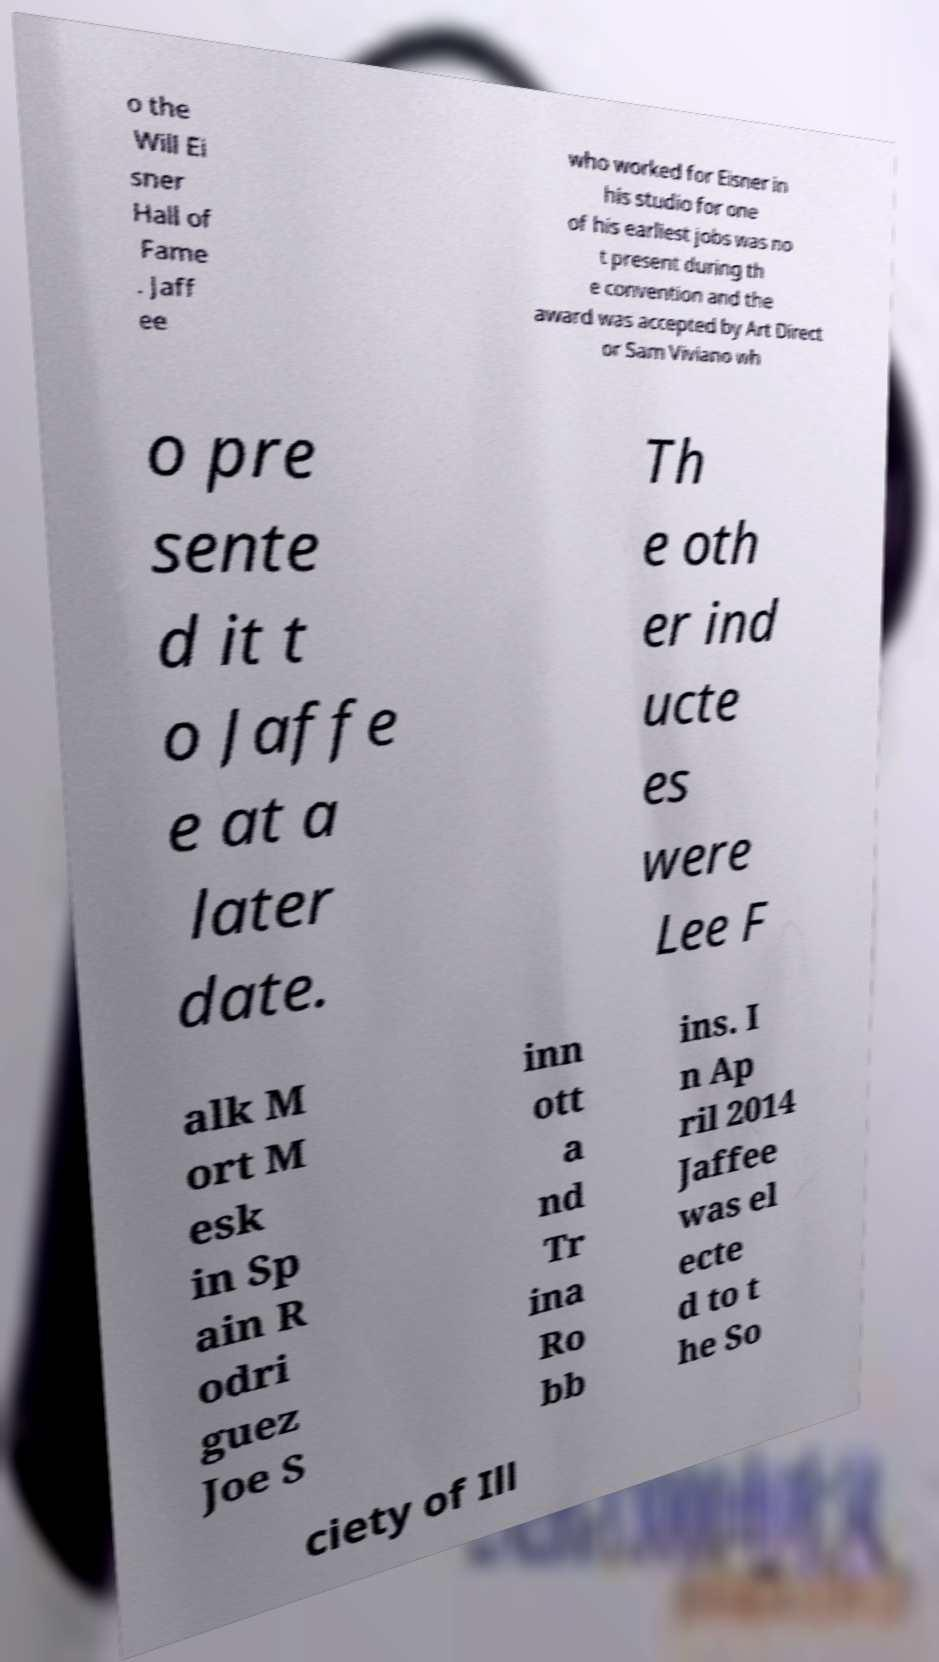Can you accurately transcribe the text from the provided image for me? o the Will Ei sner Hall of Fame . Jaff ee who worked for Eisner in his studio for one of his earliest jobs was no t present during th e convention and the award was accepted by Art Direct or Sam Viviano wh o pre sente d it t o Jaffe e at a later date. Th e oth er ind ucte es were Lee F alk M ort M esk in Sp ain R odri guez Joe S inn ott a nd Tr ina Ro bb ins. I n Ap ril 2014 Jaffee was el ecte d to t he So ciety of Ill 